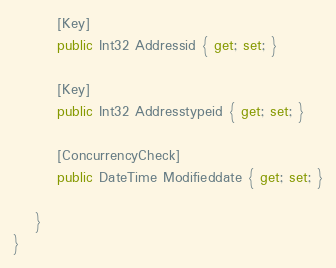Convert code to text. <code><loc_0><loc_0><loc_500><loc_500><_C#_>        [Key]
        public Int32 Addressid { get; set; }

        [Key]
        public Int32 Addresstypeid { get; set; }

        [ConcurrencyCheck]
        public DateTime Modifieddate { get; set; }

    }
}
</code> 